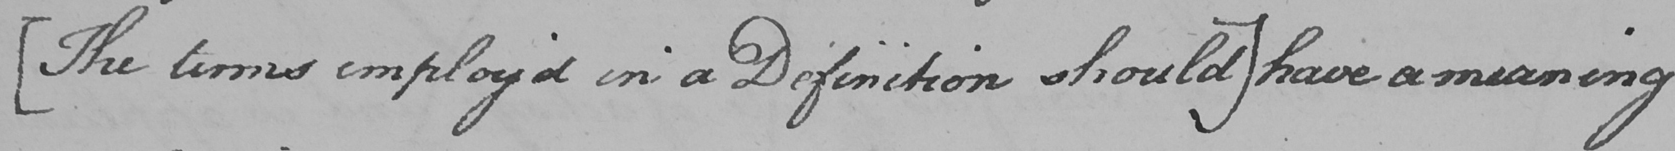Transcribe the text shown in this historical manuscript line. [ The terms employ ' d in a Definition should ]  have a meaning 